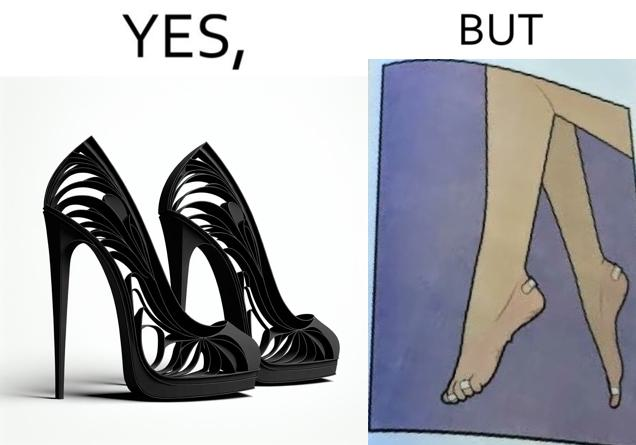What is shown in this image? The images are funny since they show how the prettiest footwears like high heels, end up causing a lot of physical discomfort to the user, all in the name fashion 